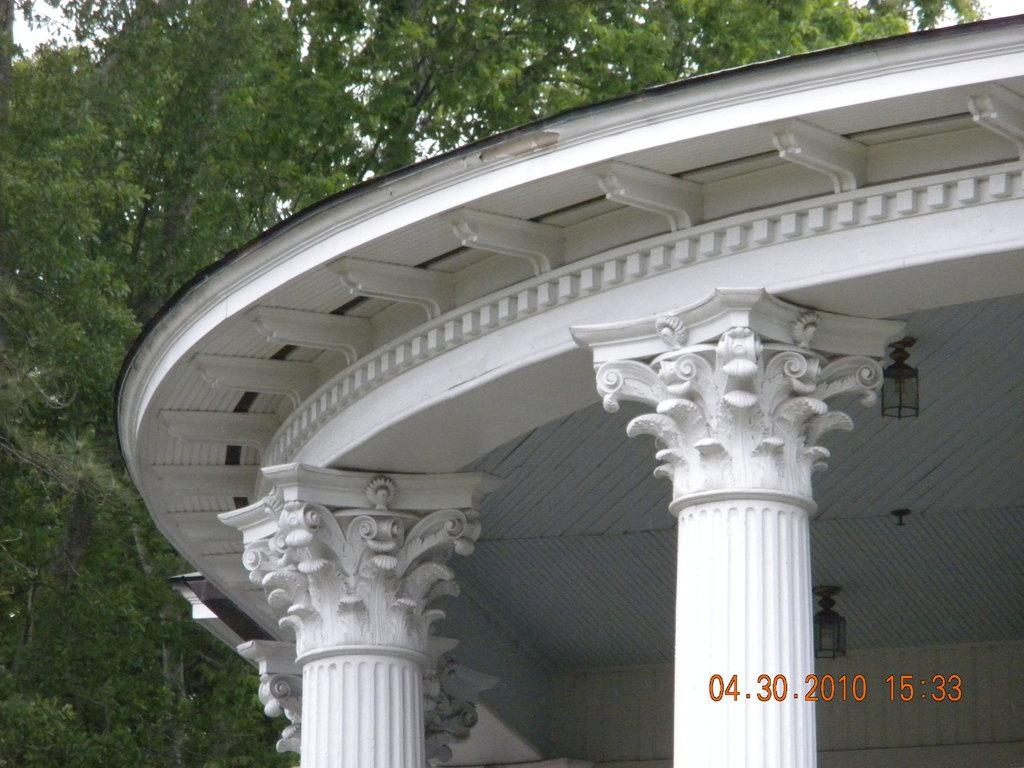What is the main subject of the image? The main subject of the image is a construction site. What can be observed about the color of the construction site? The construction site is predominantly white in color. What type of vegetation is on the left side of the image? There are trees on the left side of the image. Can you tell me how many whips are being used at the construction site in the image? There is no mention of whips being used at the construction site in the image. Is the son of the construction site manager visible in the image? There is no information about the construction site manager or their son in the image. 